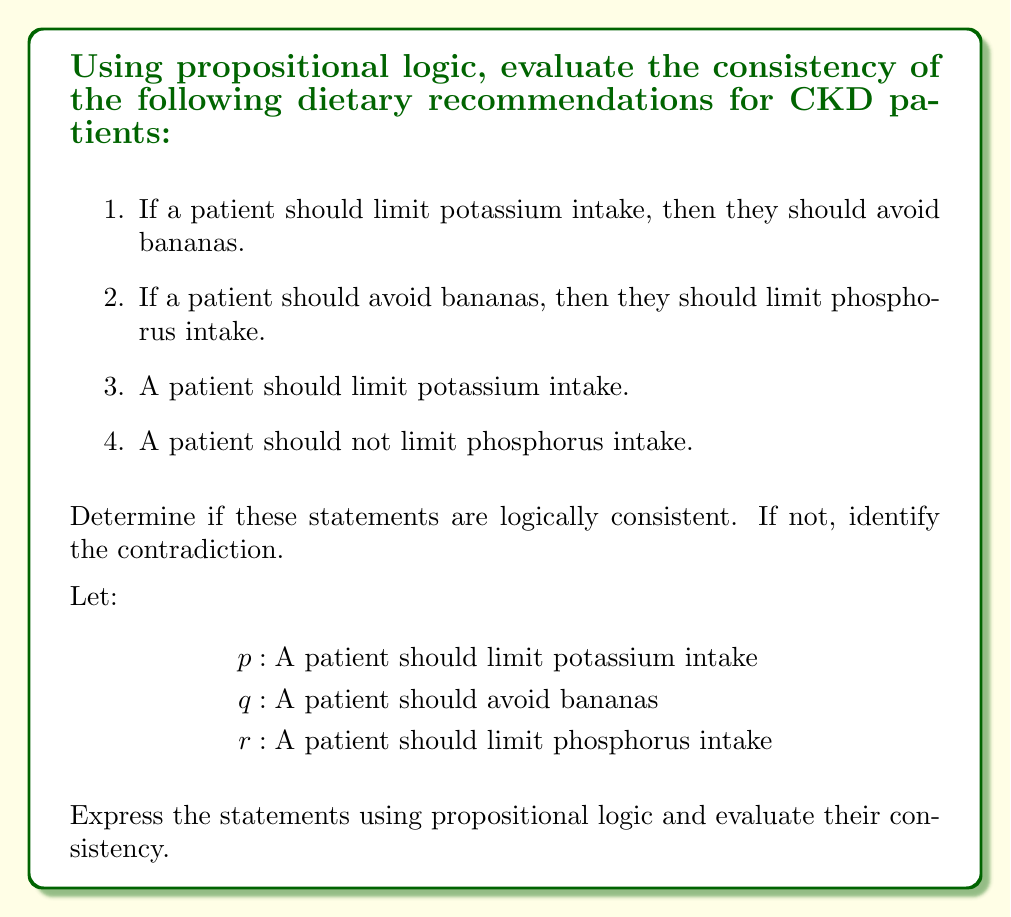Show me your answer to this math problem. Let's approach this step-by-step:

1) First, we'll express each statement using propositional logic:

   Statement 1: $p \rightarrow q$
   Statement 2: $q \rightarrow r$
   Statement 3: $p$
   Statement 4: $\neg r$

2) Now, we'll use the rules of inference to determine if these statements are consistent.

3) From statements 1 and 3, we can use Modus Ponens:
   $p \rightarrow q$
   $p$
   Therefore, $q$

4) From step 3 and statement 2, we can again use Modus Ponens:
   $q \rightarrow r$
   $q$
   Therefore, $r$

5) However, statement 4 asserts $\neg r$

6) We now have both $r$ and $\neg r$, which is a contradiction.

7) In propositional logic, if we can derive a contradiction from a set of statements, it means that the set of statements is inconsistent.

8) The contradiction arises because:
   - We're told a patient should limit potassium intake (statement 3)
   - This implies they should avoid bananas (from statement 1)
   - Avoiding bananas implies limiting phosphorus intake (from statement 2)
   - But we're also told the patient should not limit phosphorus intake (statement 4)

This contradiction highlights the importance of carefully considering the implications of dietary recommendations for CKD patients, as seemingly unrelated restrictions can lead to conflicting advice.
Answer: The statements are inconsistent due to the contradiction between $r$ and $\neg r$. 